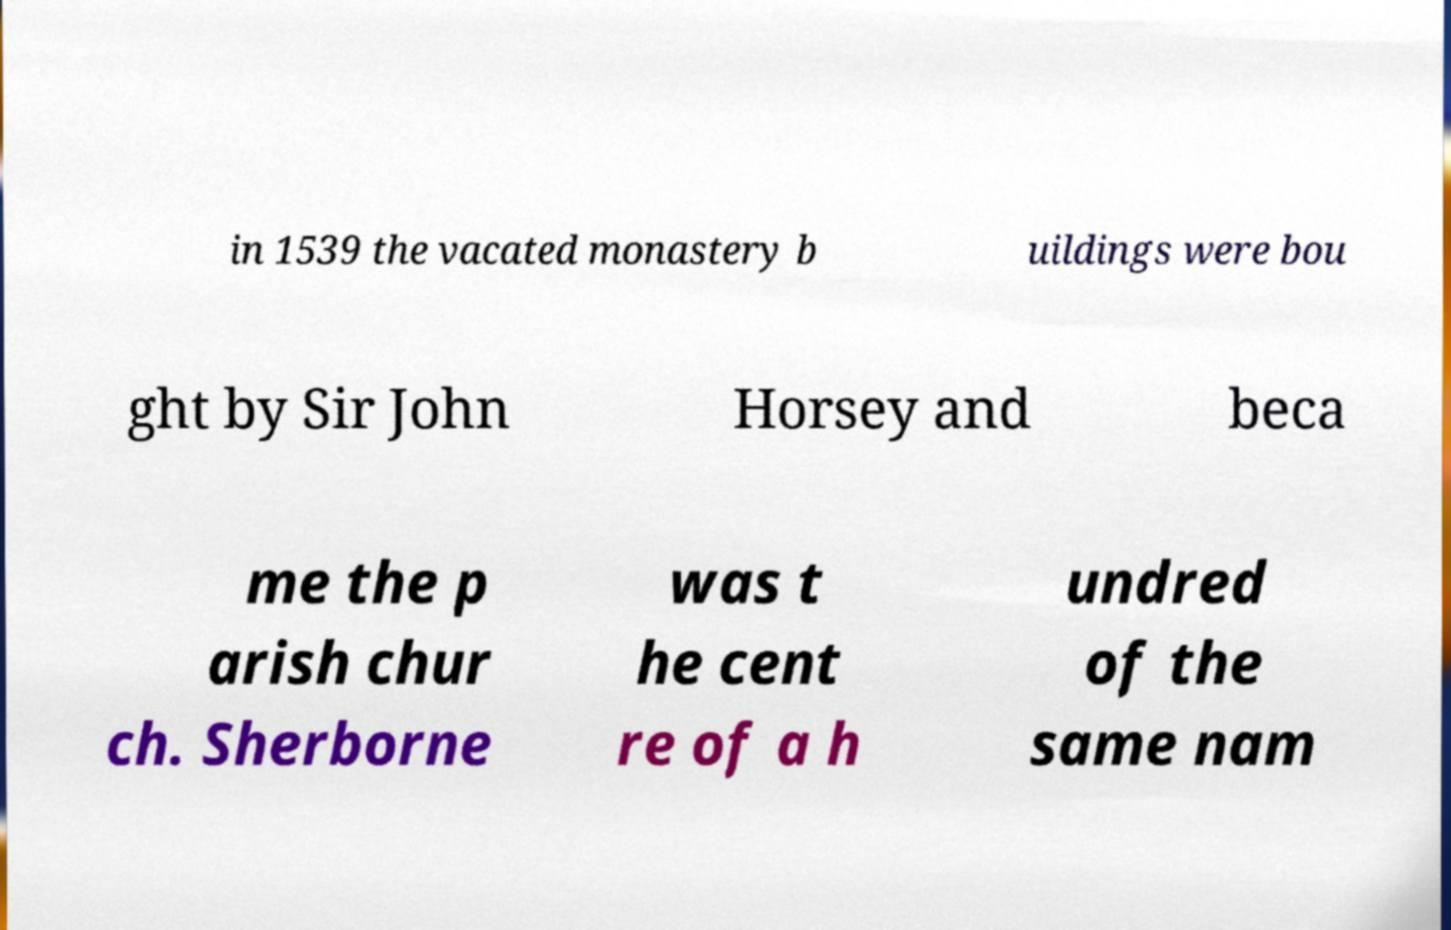For documentation purposes, I need the text within this image transcribed. Could you provide that? in 1539 the vacated monastery b uildings were bou ght by Sir John Horsey and beca me the p arish chur ch. Sherborne was t he cent re of a h undred of the same nam 